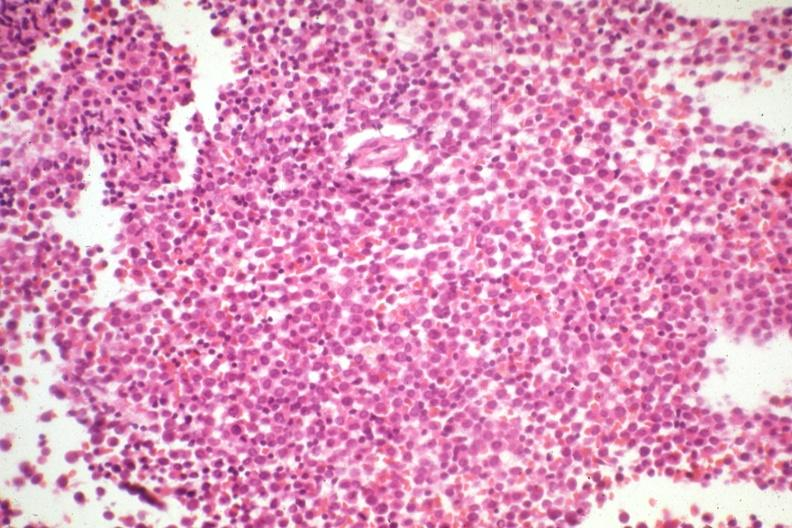s single metastatic appearing lesion present?
Answer the question using a single word or phrase. No 